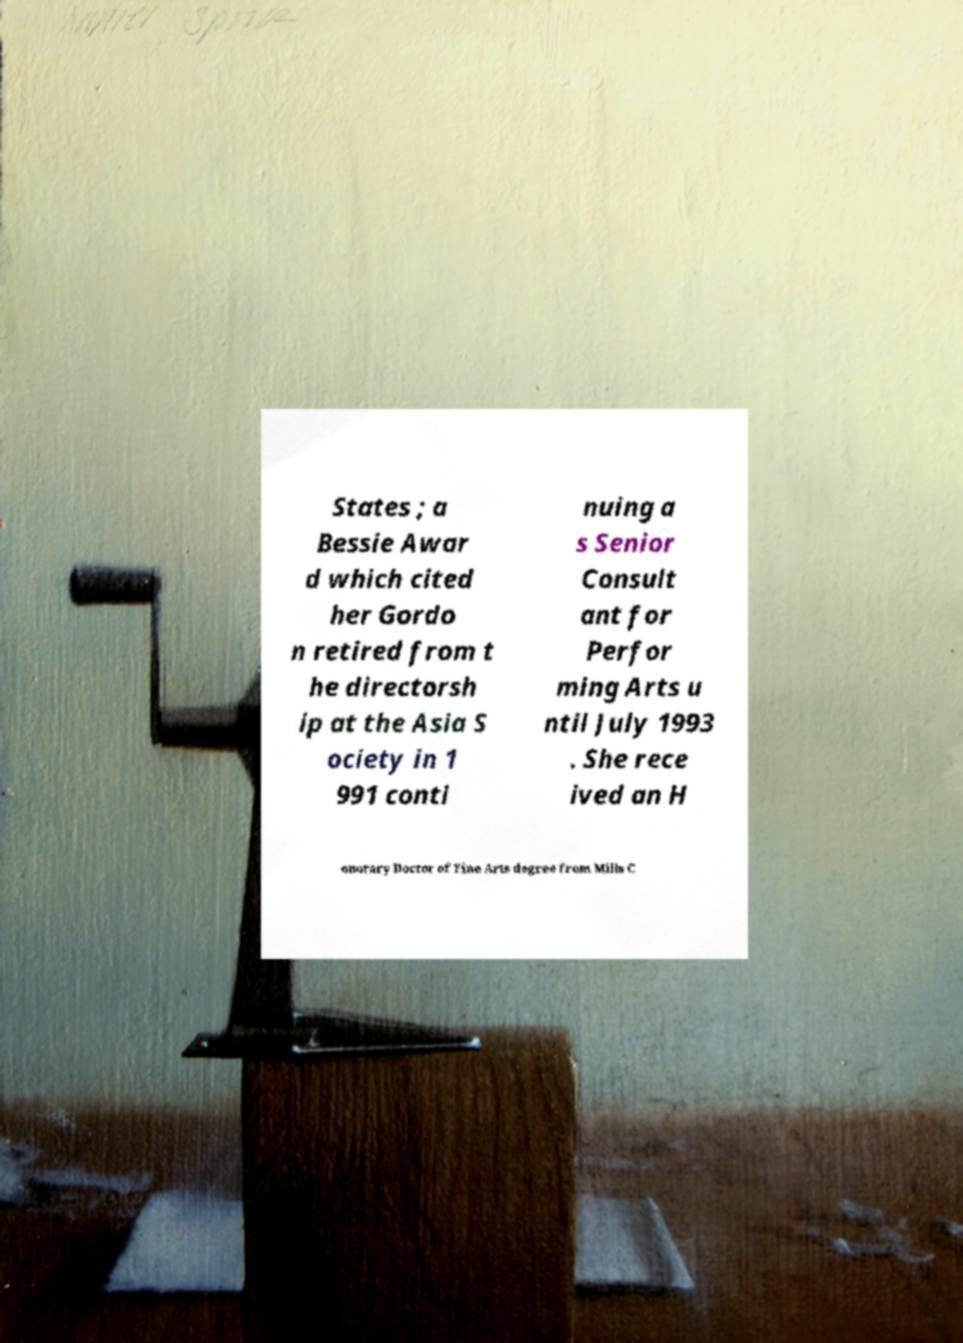Please read and relay the text visible in this image. What does it say? States ; a Bessie Awar d which cited her Gordo n retired from t he directorsh ip at the Asia S ociety in 1 991 conti nuing a s Senior Consult ant for Perfor ming Arts u ntil July 1993 . She rece ived an H onorary Doctor of Fine Arts degree from Mills C 